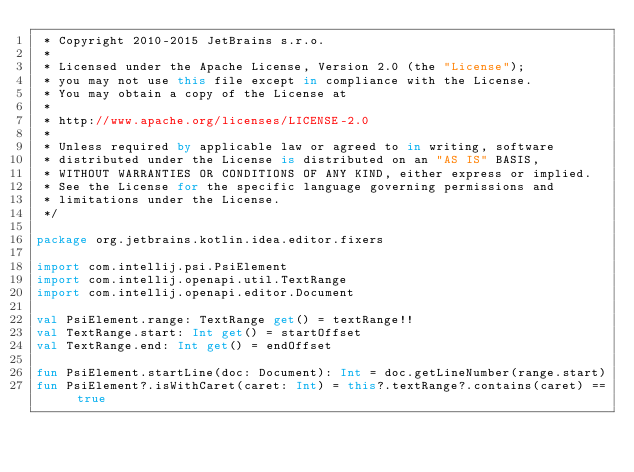<code> <loc_0><loc_0><loc_500><loc_500><_Kotlin_> * Copyright 2010-2015 JetBrains s.r.o.
 *
 * Licensed under the Apache License, Version 2.0 (the "License");
 * you may not use this file except in compliance with the License.
 * You may obtain a copy of the License at
 *
 * http://www.apache.org/licenses/LICENSE-2.0
 *
 * Unless required by applicable law or agreed to in writing, software
 * distributed under the License is distributed on an "AS IS" BASIS,
 * WITHOUT WARRANTIES OR CONDITIONS OF ANY KIND, either express or implied.
 * See the License for the specific language governing permissions and
 * limitations under the License.
 */

package org.jetbrains.kotlin.idea.editor.fixers

import com.intellij.psi.PsiElement
import com.intellij.openapi.util.TextRange
import com.intellij.openapi.editor.Document

val PsiElement.range: TextRange get() = textRange!!
val TextRange.start: Int get() = startOffset
val TextRange.end: Int get() = endOffset

fun PsiElement.startLine(doc: Document): Int = doc.getLineNumber(range.start)
fun PsiElement?.isWithCaret(caret: Int) = this?.textRange?.contains(caret) == true
</code> 